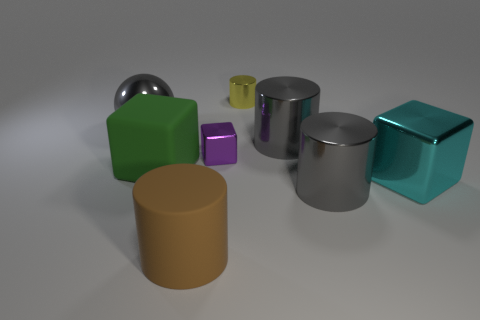What number of large cyan shiny cubes are there?
Offer a very short reply. 1. Is the number of big green rubber objects to the left of the green block less than the number of spheres?
Provide a short and direct response. Yes. Do the big cylinder behind the large cyan metallic thing and the brown thing have the same material?
Your response must be concise. No. There is a tiny object behind the gray cylinder behind the shiny cylinder in front of the big cyan cube; what is its shape?
Provide a short and direct response. Cylinder. Are there any blocks of the same size as the purple metallic thing?
Ensure brevity in your answer.  No. The purple thing has what size?
Your answer should be compact. Small. What number of purple things are the same size as the yellow metallic object?
Make the answer very short. 1. Is the number of shiny cubes that are on the right side of the tiny metal cube less than the number of things behind the big brown matte thing?
Keep it short and to the point. Yes. What is the size of the green rubber thing left of the gray cylinder on the left side of the large gray cylinder that is in front of the small metallic cube?
Provide a succinct answer. Large. There is a gray metal object that is on the right side of the gray ball and behind the cyan object; what size is it?
Your response must be concise. Large. 